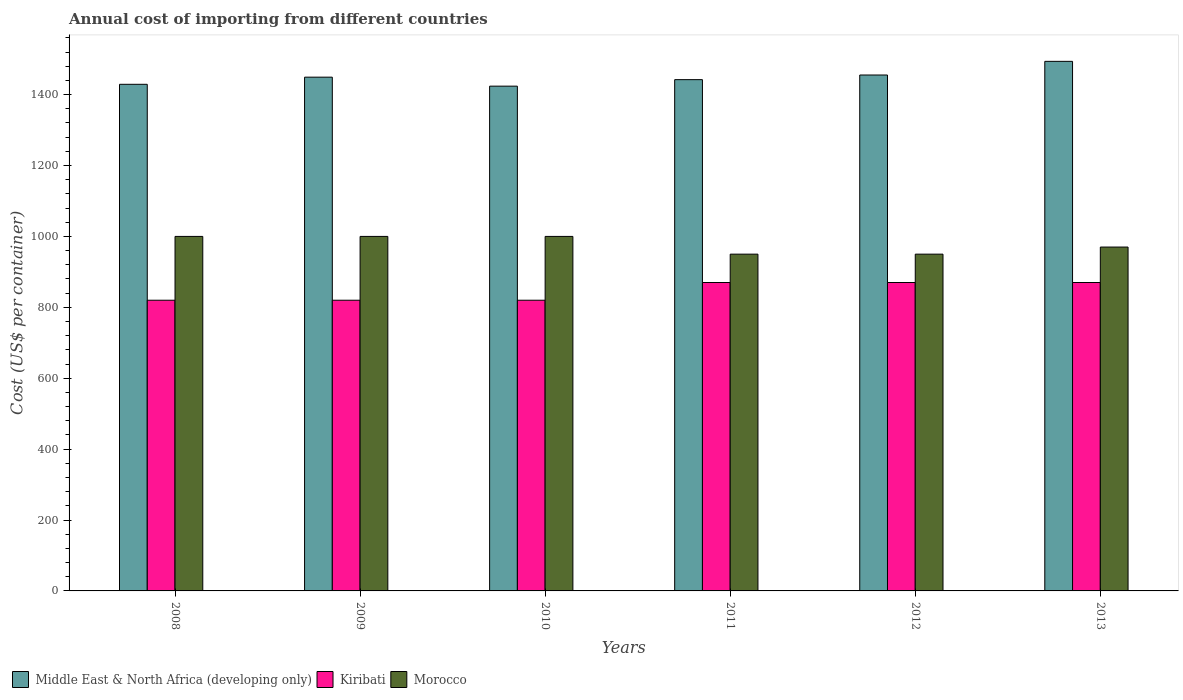How many different coloured bars are there?
Give a very brief answer. 3. How many groups of bars are there?
Your response must be concise. 6. How many bars are there on the 3rd tick from the right?
Offer a terse response. 3. What is the label of the 2nd group of bars from the left?
Offer a terse response. 2009. What is the total annual cost of importing in Morocco in 2013?
Keep it short and to the point. 970. Across all years, what is the maximum total annual cost of importing in Morocco?
Your answer should be very brief. 1000. Across all years, what is the minimum total annual cost of importing in Morocco?
Offer a very short reply. 950. In which year was the total annual cost of importing in Middle East & North Africa (developing only) maximum?
Your answer should be very brief. 2013. What is the total total annual cost of importing in Morocco in the graph?
Make the answer very short. 5870. What is the difference between the total annual cost of importing in Kiribati in 2008 and that in 2011?
Provide a succinct answer. -50. What is the difference between the total annual cost of importing in Morocco in 2008 and the total annual cost of importing in Middle East & North Africa (developing only) in 2012?
Your answer should be compact. -455.31. What is the average total annual cost of importing in Kiribati per year?
Make the answer very short. 845. In the year 2009, what is the difference between the total annual cost of importing in Morocco and total annual cost of importing in Kiribati?
Provide a succinct answer. 180. In how many years, is the total annual cost of importing in Kiribati greater than 600 US$?
Ensure brevity in your answer.  6. Is the total annual cost of importing in Middle East & North Africa (developing only) in 2009 less than that in 2011?
Make the answer very short. No. Is the difference between the total annual cost of importing in Morocco in 2008 and 2011 greater than the difference between the total annual cost of importing in Kiribati in 2008 and 2011?
Offer a terse response. Yes. What is the difference between the highest and the lowest total annual cost of importing in Middle East & North Africa (developing only)?
Provide a short and direct response. 69.93. Is the sum of the total annual cost of importing in Kiribati in 2009 and 2012 greater than the maximum total annual cost of importing in Morocco across all years?
Offer a terse response. Yes. What does the 1st bar from the left in 2010 represents?
Your response must be concise. Middle East & North Africa (developing only). What does the 3rd bar from the right in 2010 represents?
Your answer should be compact. Middle East & North Africa (developing only). Is it the case that in every year, the sum of the total annual cost of importing in Kiribati and total annual cost of importing in Middle East & North Africa (developing only) is greater than the total annual cost of importing in Morocco?
Offer a very short reply. Yes. Are all the bars in the graph horizontal?
Provide a short and direct response. No. How many years are there in the graph?
Your answer should be very brief. 6. Does the graph contain grids?
Your answer should be compact. No. Where does the legend appear in the graph?
Ensure brevity in your answer.  Bottom left. How are the legend labels stacked?
Your response must be concise. Horizontal. What is the title of the graph?
Ensure brevity in your answer.  Annual cost of importing from different countries. Does "Other small states" appear as one of the legend labels in the graph?
Ensure brevity in your answer.  No. What is the label or title of the Y-axis?
Offer a very short reply. Cost (US$ per container). What is the Cost (US$ per container) of Middle East & North Africa (developing only) in 2008?
Provide a short and direct response. 1429.08. What is the Cost (US$ per container) in Kiribati in 2008?
Make the answer very short. 820. What is the Cost (US$ per container) of Middle East & North Africa (developing only) in 2009?
Offer a very short reply. 1449.25. What is the Cost (US$ per container) of Kiribati in 2009?
Offer a very short reply. 820. What is the Cost (US$ per container) in Morocco in 2009?
Ensure brevity in your answer.  1000. What is the Cost (US$ per container) in Middle East & North Africa (developing only) in 2010?
Give a very brief answer. 1423.92. What is the Cost (US$ per container) of Kiribati in 2010?
Provide a succinct answer. 820. What is the Cost (US$ per container) in Morocco in 2010?
Keep it short and to the point. 1000. What is the Cost (US$ per container) of Middle East & North Africa (developing only) in 2011?
Ensure brevity in your answer.  1442.25. What is the Cost (US$ per container) of Kiribati in 2011?
Your answer should be very brief. 870. What is the Cost (US$ per container) in Morocco in 2011?
Your response must be concise. 950. What is the Cost (US$ per container) of Middle East & North Africa (developing only) in 2012?
Your response must be concise. 1455.31. What is the Cost (US$ per container) in Kiribati in 2012?
Offer a very short reply. 870. What is the Cost (US$ per container) in Morocco in 2012?
Keep it short and to the point. 950. What is the Cost (US$ per container) in Middle East & North Africa (developing only) in 2013?
Ensure brevity in your answer.  1493.85. What is the Cost (US$ per container) of Kiribati in 2013?
Give a very brief answer. 870. What is the Cost (US$ per container) in Morocco in 2013?
Give a very brief answer. 970. Across all years, what is the maximum Cost (US$ per container) in Middle East & North Africa (developing only)?
Keep it short and to the point. 1493.85. Across all years, what is the maximum Cost (US$ per container) in Kiribati?
Your response must be concise. 870. Across all years, what is the minimum Cost (US$ per container) in Middle East & North Africa (developing only)?
Your answer should be compact. 1423.92. Across all years, what is the minimum Cost (US$ per container) of Kiribati?
Offer a terse response. 820. Across all years, what is the minimum Cost (US$ per container) in Morocco?
Give a very brief answer. 950. What is the total Cost (US$ per container) in Middle East & North Africa (developing only) in the graph?
Offer a very short reply. 8693.65. What is the total Cost (US$ per container) in Kiribati in the graph?
Offer a terse response. 5070. What is the total Cost (US$ per container) of Morocco in the graph?
Your answer should be compact. 5870. What is the difference between the Cost (US$ per container) in Middle East & North Africa (developing only) in 2008 and that in 2009?
Give a very brief answer. -20.17. What is the difference between the Cost (US$ per container) of Kiribati in 2008 and that in 2009?
Make the answer very short. 0. What is the difference between the Cost (US$ per container) of Morocco in 2008 and that in 2009?
Offer a terse response. 0. What is the difference between the Cost (US$ per container) in Middle East & North Africa (developing only) in 2008 and that in 2010?
Provide a short and direct response. 5.17. What is the difference between the Cost (US$ per container) in Kiribati in 2008 and that in 2010?
Your response must be concise. 0. What is the difference between the Cost (US$ per container) of Middle East & North Africa (developing only) in 2008 and that in 2011?
Provide a short and direct response. -13.17. What is the difference between the Cost (US$ per container) in Morocco in 2008 and that in 2011?
Give a very brief answer. 50. What is the difference between the Cost (US$ per container) in Middle East & North Africa (developing only) in 2008 and that in 2012?
Provide a succinct answer. -26.22. What is the difference between the Cost (US$ per container) in Kiribati in 2008 and that in 2012?
Provide a short and direct response. -50. What is the difference between the Cost (US$ per container) of Middle East & North Africa (developing only) in 2008 and that in 2013?
Provide a succinct answer. -64.76. What is the difference between the Cost (US$ per container) in Kiribati in 2008 and that in 2013?
Your answer should be very brief. -50. What is the difference between the Cost (US$ per container) in Morocco in 2008 and that in 2013?
Your answer should be compact. 30. What is the difference between the Cost (US$ per container) of Middle East & North Africa (developing only) in 2009 and that in 2010?
Your response must be concise. 25.33. What is the difference between the Cost (US$ per container) in Kiribati in 2009 and that in 2011?
Ensure brevity in your answer.  -50. What is the difference between the Cost (US$ per container) in Morocco in 2009 and that in 2011?
Keep it short and to the point. 50. What is the difference between the Cost (US$ per container) in Middle East & North Africa (developing only) in 2009 and that in 2012?
Ensure brevity in your answer.  -6.06. What is the difference between the Cost (US$ per container) in Kiribati in 2009 and that in 2012?
Your response must be concise. -50. What is the difference between the Cost (US$ per container) of Middle East & North Africa (developing only) in 2009 and that in 2013?
Offer a terse response. -44.6. What is the difference between the Cost (US$ per container) in Middle East & North Africa (developing only) in 2010 and that in 2011?
Offer a terse response. -18.33. What is the difference between the Cost (US$ per container) of Kiribati in 2010 and that in 2011?
Give a very brief answer. -50. What is the difference between the Cost (US$ per container) in Middle East & North Africa (developing only) in 2010 and that in 2012?
Provide a short and direct response. -31.39. What is the difference between the Cost (US$ per container) in Kiribati in 2010 and that in 2012?
Ensure brevity in your answer.  -50. What is the difference between the Cost (US$ per container) of Middle East & North Africa (developing only) in 2010 and that in 2013?
Give a very brief answer. -69.93. What is the difference between the Cost (US$ per container) of Middle East & North Africa (developing only) in 2011 and that in 2012?
Offer a very short reply. -13.06. What is the difference between the Cost (US$ per container) of Middle East & North Africa (developing only) in 2011 and that in 2013?
Keep it short and to the point. -51.6. What is the difference between the Cost (US$ per container) in Morocco in 2011 and that in 2013?
Ensure brevity in your answer.  -20. What is the difference between the Cost (US$ per container) of Middle East & North Africa (developing only) in 2012 and that in 2013?
Offer a very short reply. -38.54. What is the difference between the Cost (US$ per container) of Middle East & North Africa (developing only) in 2008 and the Cost (US$ per container) of Kiribati in 2009?
Ensure brevity in your answer.  609.08. What is the difference between the Cost (US$ per container) in Middle East & North Africa (developing only) in 2008 and the Cost (US$ per container) in Morocco in 2009?
Ensure brevity in your answer.  429.08. What is the difference between the Cost (US$ per container) in Kiribati in 2008 and the Cost (US$ per container) in Morocco in 2009?
Give a very brief answer. -180. What is the difference between the Cost (US$ per container) of Middle East & North Africa (developing only) in 2008 and the Cost (US$ per container) of Kiribati in 2010?
Ensure brevity in your answer.  609.08. What is the difference between the Cost (US$ per container) in Middle East & North Africa (developing only) in 2008 and the Cost (US$ per container) in Morocco in 2010?
Keep it short and to the point. 429.08. What is the difference between the Cost (US$ per container) in Kiribati in 2008 and the Cost (US$ per container) in Morocco in 2010?
Your answer should be very brief. -180. What is the difference between the Cost (US$ per container) in Middle East & North Africa (developing only) in 2008 and the Cost (US$ per container) in Kiribati in 2011?
Offer a terse response. 559.08. What is the difference between the Cost (US$ per container) in Middle East & North Africa (developing only) in 2008 and the Cost (US$ per container) in Morocco in 2011?
Ensure brevity in your answer.  479.08. What is the difference between the Cost (US$ per container) of Kiribati in 2008 and the Cost (US$ per container) of Morocco in 2011?
Offer a terse response. -130. What is the difference between the Cost (US$ per container) in Middle East & North Africa (developing only) in 2008 and the Cost (US$ per container) in Kiribati in 2012?
Offer a very short reply. 559.08. What is the difference between the Cost (US$ per container) of Middle East & North Africa (developing only) in 2008 and the Cost (US$ per container) of Morocco in 2012?
Give a very brief answer. 479.08. What is the difference between the Cost (US$ per container) in Kiribati in 2008 and the Cost (US$ per container) in Morocco in 2012?
Provide a short and direct response. -130. What is the difference between the Cost (US$ per container) of Middle East & North Africa (developing only) in 2008 and the Cost (US$ per container) of Kiribati in 2013?
Give a very brief answer. 559.08. What is the difference between the Cost (US$ per container) of Middle East & North Africa (developing only) in 2008 and the Cost (US$ per container) of Morocco in 2013?
Make the answer very short. 459.08. What is the difference between the Cost (US$ per container) in Kiribati in 2008 and the Cost (US$ per container) in Morocco in 2013?
Ensure brevity in your answer.  -150. What is the difference between the Cost (US$ per container) of Middle East & North Africa (developing only) in 2009 and the Cost (US$ per container) of Kiribati in 2010?
Keep it short and to the point. 629.25. What is the difference between the Cost (US$ per container) of Middle East & North Africa (developing only) in 2009 and the Cost (US$ per container) of Morocco in 2010?
Provide a succinct answer. 449.25. What is the difference between the Cost (US$ per container) of Kiribati in 2009 and the Cost (US$ per container) of Morocco in 2010?
Your answer should be very brief. -180. What is the difference between the Cost (US$ per container) of Middle East & North Africa (developing only) in 2009 and the Cost (US$ per container) of Kiribati in 2011?
Your response must be concise. 579.25. What is the difference between the Cost (US$ per container) of Middle East & North Africa (developing only) in 2009 and the Cost (US$ per container) of Morocco in 2011?
Offer a very short reply. 499.25. What is the difference between the Cost (US$ per container) of Kiribati in 2009 and the Cost (US$ per container) of Morocco in 2011?
Ensure brevity in your answer.  -130. What is the difference between the Cost (US$ per container) of Middle East & North Africa (developing only) in 2009 and the Cost (US$ per container) of Kiribati in 2012?
Provide a short and direct response. 579.25. What is the difference between the Cost (US$ per container) of Middle East & North Africa (developing only) in 2009 and the Cost (US$ per container) of Morocco in 2012?
Provide a short and direct response. 499.25. What is the difference between the Cost (US$ per container) in Kiribati in 2009 and the Cost (US$ per container) in Morocco in 2012?
Provide a succinct answer. -130. What is the difference between the Cost (US$ per container) in Middle East & North Africa (developing only) in 2009 and the Cost (US$ per container) in Kiribati in 2013?
Provide a succinct answer. 579.25. What is the difference between the Cost (US$ per container) of Middle East & North Africa (developing only) in 2009 and the Cost (US$ per container) of Morocco in 2013?
Give a very brief answer. 479.25. What is the difference between the Cost (US$ per container) in Kiribati in 2009 and the Cost (US$ per container) in Morocco in 2013?
Provide a succinct answer. -150. What is the difference between the Cost (US$ per container) in Middle East & North Africa (developing only) in 2010 and the Cost (US$ per container) in Kiribati in 2011?
Offer a terse response. 553.92. What is the difference between the Cost (US$ per container) of Middle East & North Africa (developing only) in 2010 and the Cost (US$ per container) of Morocco in 2011?
Offer a very short reply. 473.92. What is the difference between the Cost (US$ per container) of Kiribati in 2010 and the Cost (US$ per container) of Morocco in 2011?
Offer a very short reply. -130. What is the difference between the Cost (US$ per container) of Middle East & North Africa (developing only) in 2010 and the Cost (US$ per container) of Kiribati in 2012?
Provide a succinct answer. 553.92. What is the difference between the Cost (US$ per container) in Middle East & North Africa (developing only) in 2010 and the Cost (US$ per container) in Morocco in 2012?
Keep it short and to the point. 473.92. What is the difference between the Cost (US$ per container) in Kiribati in 2010 and the Cost (US$ per container) in Morocco in 2012?
Your answer should be compact. -130. What is the difference between the Cost (US$ per container) of Middle East & North Africa (developing only) in 2010 and the Cost (US$ per container) of Kiribati in 2013?
Keep it short and to the point. 553.92. What is the difference between the Cost (US$ per container) of Middle East & North Africa (developing only) in 2010 and the Cost (US$ per container) of Morocco in 2013?
Your answer should be compact. 453.92. What is the difference between the Cost (US$ per container) in Kiribati in 2010 and the Cost (US$ per container) in Morocco in 2013?
Offer a very short reply. -150. What is the difference between the Cost (US$ per container) of Middle East & North Africa (developing only) in 2011 and the Cost (US$ per container) of Kiribati in 2012?
Provide a short and direct response. 572.25. What is the difference between the Cost (US$ per container) in Middle East & North Africa (developing only) in 2011 and the Cost (US$ per container) in Morocco in 2012?
Keep it short and to the point. 492.25. What is the difference between the Cost (US$ per container) in Kiribati in 2011 and the Cost (US$ per container) in Morocco in 2012?
Make the answer very short. -80. What is the difference between the Cost (US$ per container) in Middle East & North Africa (developing only) in 2011 and the Cost (US$ per container) in Kiribati in 2013?
Your answer should be very brief. 572.25. What is the difference between the Cost (US$ per container) of Middle East & North Africa (developing only) in 2011 and the Cost (US$ per container) of Morocco in 2013?
Ensure brevity in your answer.  472.25. What is the difference between the Cost (US$ per container) in Kiribati in 2011 and the Cost (US$ per container) in Morocco in 2013?
Offer a very short reply. -100. What is the difference between the Cost (US$ per container) of Middle East & North Africa (developing only) in 2012 and the Cost (US$ per container) of Kiribati in 2013?
Offer a terse response. 585.31. What is the difference between the Cost (US$ per container) in Middle East & North Africa (developing only) in 2012 and the Cost (US$ per container) in Morocco in 2013?
Your response must be concise. 485.31. What is the difference between the Cost (US$ per container) in Kiribati in 2012 and the Cost (US$ per container) in Morocco in 2013?
Your answer should be very brief. -100. What is the average Cost (US$ per container) of Middle East & North Africa (developing only) per year?
Your response must be concise. 1448.94. What is the average Cost (US$ per container) of Kiribati per year?
Provide a succinct answer. 845. What is the average Cost (US$ per container) of Morocco per year?
Provide a short and direct response. 978.33. In the year 2008, what is the difference between the Cost (US$ per container) in Middle East & North Africa (developing only) and Cost (US$ per container) in Kiribati?
Offer a terse response. 609.08. In the year 2008, what is the difference between the Cost (US$ per container) of Middle East & North Africa (developing only) and Cost (US$ per container) of Morocco?
Provide a short and direct response. 429.08. In the year 2008, what is the difference between the Cost (US$ per container) of Kiribati and Cost (US$ per container) of Morocco?
Provide a succinct answer. -180. In the year 2009, what is the difference between the Cost (US$ per container) of Middle East & North Africa (developing only) and Cost (US$ per container) of Kiribati?
Provide a succinct answer. 629.25. In the year 2009, what is the difference between the Cost (US$ per container) of Middle East & North Africa (developing only) and Cost (US$ per container) of Morocco?
Give a very brief answer. 449.25. In the year 2009, what is the difference between the Cost (US$ per container) in Kiribati and Cost (US$ per container) in Morocco?
Offer a very short reply. -180. In the year 2010, what is the difference between the Cost (US$ per container) in Middle East & North Africa (developing only) and Cost (US$ per container) in Kiribati?
Your answer should be compact. 603.92. In the year 2010, what is the difference between the Cost (US$ per container) in Middle East & North Africa (developing only) and Cost (US$ per container) in Morocco?
Offer a very short reply. 423.92. In the year 2010, what is the difference between the Cost (US$ per container) in Kiribati and Cost (US$ per container) in Morocco?
Your answer should be very brief. -180. In the year 2011, what is the difference between the Cost (US$ per container) in Middle East & North Africa (developing only) and Cost (US$ per container) in Kiribati?
Keep it short and to the point. 572.25. In the year 2011, what is the difference between the Cost (US$ per container) in Middle East & North Africa (developing only) and Cost (US$ per container) in Morocco?
Keep it short and to the point. 492.25. In the year 2011, what is the difference between the Cost (US$ per container) of Kiribati and Cost (US$ per container) of Morocco?
Make the answer very short. -80. In the year 2012, what is the difference between the Cost (US$ per container) in Middle East & North Africa (developing only) and Cost (US$ per container) in Kiribati?
Keep it short and to the point. 585.31. In the year 2012, what is the difference between the Cost (US$ per container) in Middle East & North Africa (developing only) and Cost (US$ per container) in Morocco?
Make the answer very short. 505.31. In the year 2012, what is the difference between the Cost (US$ per container) in Kiribati and Cost (US$ per container) in Morocco?
Make the answer very short. -80. In the year 2013, what is the difference between the Cost (US$ per container) in Middle East & North Africa (developing only) and Cost (US$ per container) in Kiribati?
Your response must be concise. 623.85. In the year 2013, what is the difference between the Cost (US$ per container) in Middle East & North Africa (developing only) and Cost (US$ per container) in Morocco?
Make the answer very short. 523.85. In the year 2013, what is the difference between the Cost (US$ per container) of Kiribati and Cost (US$ per container) of Morocco?
Offer a terse response. -100. What is the ratio of the Cost (US$ per container) in Middle East & North Africa (developing only) in 2008 to that in 2009?
Keep it short and to the point. 0.99. What is the ratio of the Cost (US$ per container) in Kiribati in 2008 to that in 2010?
Offer a very short reply. 1. What is the ratio of the Cost (US$ per container) of Morocco in 2008 to that in 2010?
Provide a short and direct response. 1. What is the ratio of the Cost (US$ per container) in Middle East & North Africa (developing only) in 2008 to that in 2011?
Provide a short and direct response. 0.99. What is the ratio of the Cost (US$ per container) in Kiribati in 2008 to that in 2011?
Keep it short and to the point. 0.94. What is the ratio of the Cost (US$ per container) in Morocco in 2008 to that in 2011?
Give a very brief answer. 1.05. What is the ratio of the Cost (US$ per container) of Middle East & North Africa (developing only) in 2008 to that in 2012?
Make the answer very short. 0.98. What is the ratio of the Cost (US$ per container) in Kiribati in 2008 to that in 2012?
Provide a succinct answer. 0.94. What is the ratio of the Cost (US$ per container) in Morocco in 2008 to that in 2012?
Give a very brief answer. 1.05. What is the ratio of the Cost (US$ per container) in Middle East & North Africa (developing only) in 2008 to that in 2013?
Your response must be concise. 0.96. What is the ratio of the Cost (US$ per container) of Kiribati in 2008 to that in 2013?
Provide a succinct answer. 0.94. What is the ratio of the Cost (US$ per container) in Morocco in 2008 to that in 2013?
Ensure brevity in your answer.  1.03. What is the ratio of the Cost (US$ per container) in Middle East & North Africa (developing only) in 2009 to that in 2010?
Keep it short and to the point. 1.02. What is the ratio of the Cost (US$ per container) of Morocco in 2009 to that in 2010?
Give a very brief answer. 1. What is the ratio of the Cost (US$ per container) of Kiribati in 2009 to that in 2011?
Offer a very short reply. 0.94. What is the ratio of the Cost (US$ per container) of Morocco in 2009 to that in 2011?
Your answer should be very brief. 1.05. What is the ratio of the Cost (US$ per container) of Kiribati in 2009 to that in 2012?
Ensure brevity in your answer.  0.94. What is the ratio of the Cost (US$ per container) in Morocco in 2009 to that in 2012?
Offer a very short reply. 1.05. What is the ratio of the Cost (US$ per container) of Middle East & North Africa (developing only) in 2009 to that in 2013?
Ensure brevity in your answer.  0.97. What is the ratio of the Cost (US$ per container) in Kiribati in 2009 to that in 2013?
Give a very brief answer. 0.94. What is the ratio of the Cost (US$ per container) of Morocco in 2009 to that in 2013?
Your answer should be very brief. 1.03. What is the ratio of the Cost (US$ per container) in Middle East & North Africa (developing only) in 2010 to that in 2011?
Offer a very short reply. 0.99. What is the ratio of the Cost (US$ per container) in Kiribati in 2010 to that in 2011?
Ensure brevity in your answer.  0.94. What is the ratio of the Cost (US$ per container) of Morocco in 2010 to that in 2011?
Ensure brevity in your answer.  1.05. What is the ratio of the Cost (US$ per container) in Middle East & North Africa (developing only) in 2010 to that in 2012?
Ensure brevity in your answer.  0.98. What is the ratio of the Cost (US$ per container) in Kiribati in 2010 to that in 2012?
Ensure brevity in your answer.  0.94. What is the ratio of the Cost (US$ per container) of Morocco in 2010 to that in 2012?
Provide a succinct answer. 1.05. What is the ratio of the Cost (US$ per container) of Middle East & North Africa (developing only) in 2010 to that in 2013?
Make the answer very short. 0.95. What is the ratio of the Cost (US$ per container) in Kiribati in 2010 to that in 2013?
Offer a terse response. 0.94. What is the ratio of the Cost (US$ per container) in Morocco in 2010 to that in 2013?
Offer a very short reply. 1.03. What is the ratio of the Cost (US$ per container) in Middle East & North Africa (developing only) in 2011 to that in 2012?
Your response must be concise. 0.99. What is the ratio of the Cost (US$ per container) of Kiribati in 2011 to that in 2012?
Your answer should be very brief. 1. What is the ratio of the Cost (US$ per container) of Middle East & North Africa (developing only) in 2011 to that in 2013?
Your response must be concise. 0.97. What is the ratio of the Cost (US$ per container) of Kiribati in 2011 to that in 2013?
Provide a short and direct response. 1. What is the ratio of the Cost (US$ per container) in Morocco in 2011 to that in 2013?
Offer a terse response. 0.98. What is the ratio of the Cost (US$ per container) of Middle East & North Africa (developing only) in 2012 to that in 2013?
Make the answer very short. 0.97. What is the ratio of the Cost (US$ per container) in Kiribati in 2012 to that in 2013?
Ensure brevity in your answer.  1. What is the ratio of the Cost (US$ per container) of Morocco in 2012 to that in 2013?
Offer a very short reply. 0.98. What is the difference between the highest and the second highest Cost (US$ per container) of Middle East & North Africa (developing only)?
Make the answer very short. 38.54. What is the difference between the highest and the second highest Cost (US$ per container) in Kiribati?
Offer a very short reply. 0. What is the difference between the highest and the second highest Cost (US$ per container) of Morocco?
Offer a terse response. 0. What is the difference between the highest and the lowest Cost (US$ per container) of Middle East & North Africa (developing only)?
Ensure brevity in your answer.  69.93. What is the difference between the highest and the lowest Cost (US$ per container) in Morocco?
Ensure brevity in your answer.  50. 